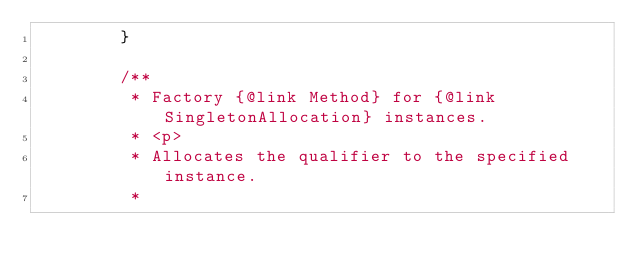Convert code to text. <code><loc_0><loc_0><loc_500><loc_500><_Java_>        }

        /**
         * Factory {@link Method} for {@link SingletonAllocation} instances.
         * <p>
         * Allocates the qualifier to the specified instance.
         *</code> 